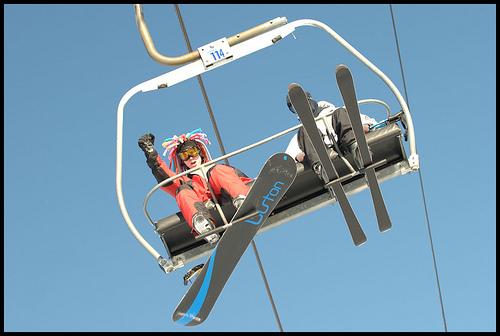How many are on the ski lift?
Answer briefly. 2. What is the name on the bottom of the snowboard?
Short answer required. Burton. Is the man waving?
Answer briefly. Yes. 